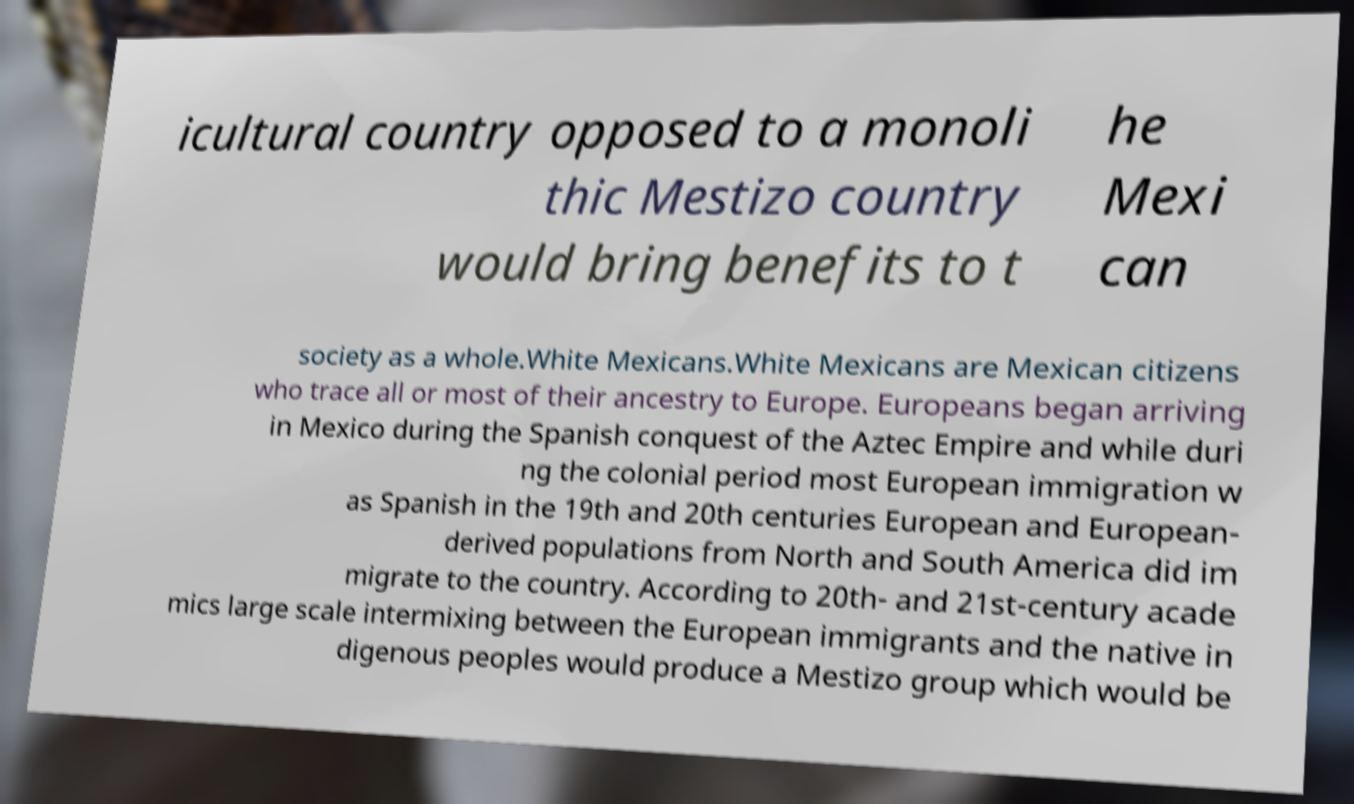For documentation purposes, I need the text within this image transcribed. Could you provide that? icultural country opposed to a monoli thic Mestizo country would bring benefits to t he Mexi can society as a whole.White Mexicans.White Mexicans are Mexican citizens who trace all or most of their ancestry to Europe. Europeans began arriving in Mexico during the Spanish conquest of the Aztec Empire and while duri ng the colonial period most European immigration w as Spanish in the 19th and 20th centuries European and European- derived populations from North and South America did im migrate to the country. According to 20th- and 21st-century acade mics large scale intermixing between the European immigrants and the native in digenous peoples would produce a Mestizo group which would be 